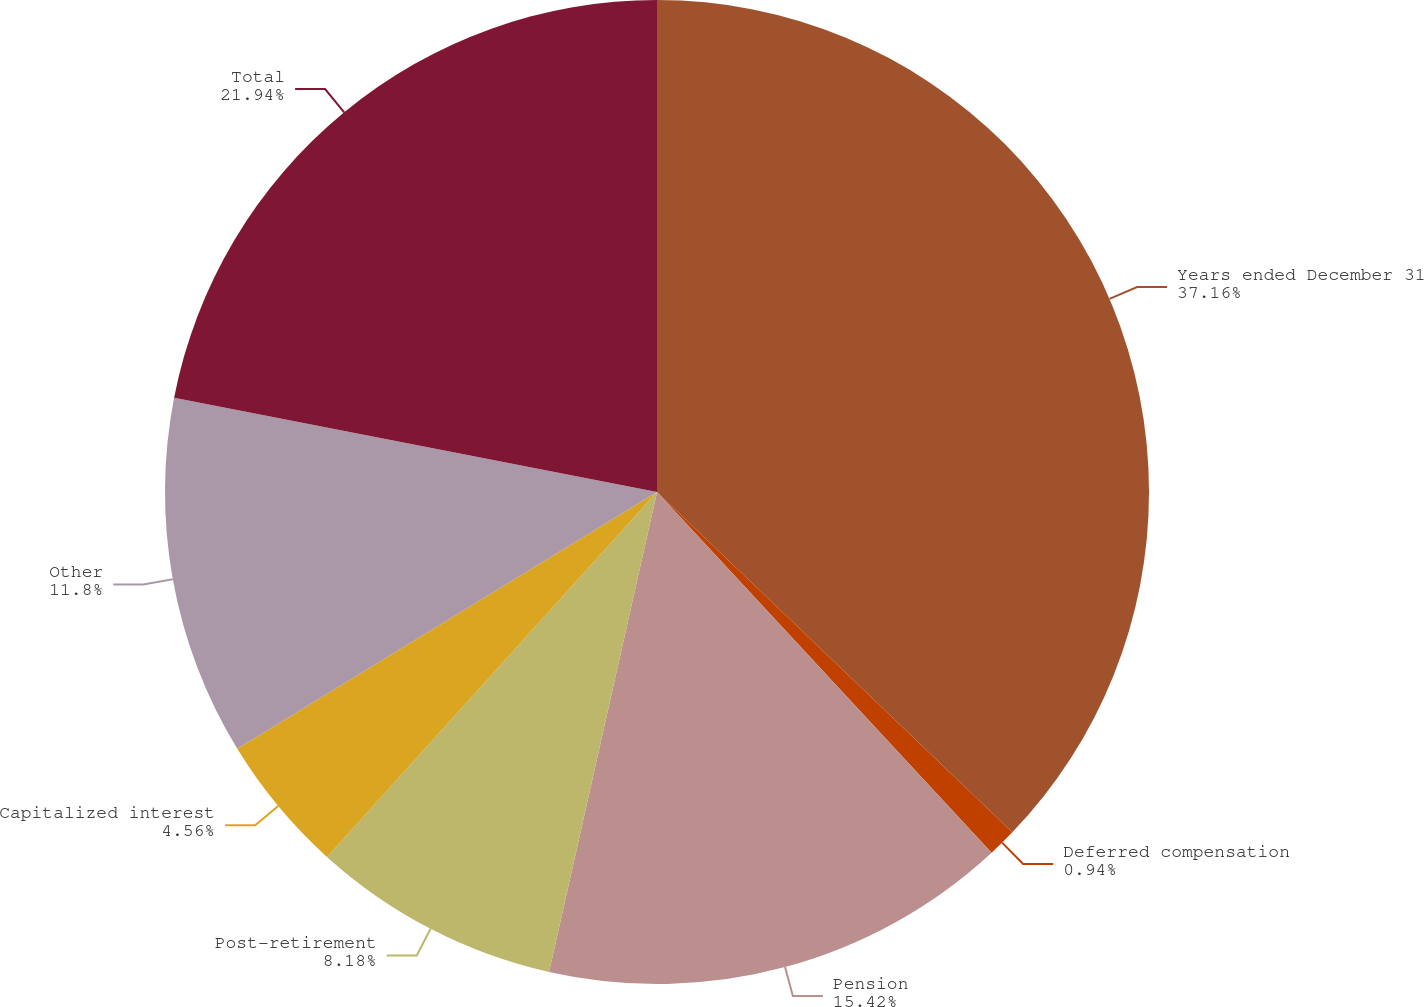Convert chart. <chart><loc_0><loc_0><loc_500><loc_500><pie_chart><fcel>Years ended December 31<fcel>Deferred compensation<fcel>Pension<fcel>Post-retirement<fcel>Capitalized interest<fcel>Other<fcel>Total<nl><fcel>37.15%<fcel>0.94%<fcel>15.42%<fcel>8.18%<fcel>4.56%<fcel>11.8%<fcel>21.93%<nl></chart> 